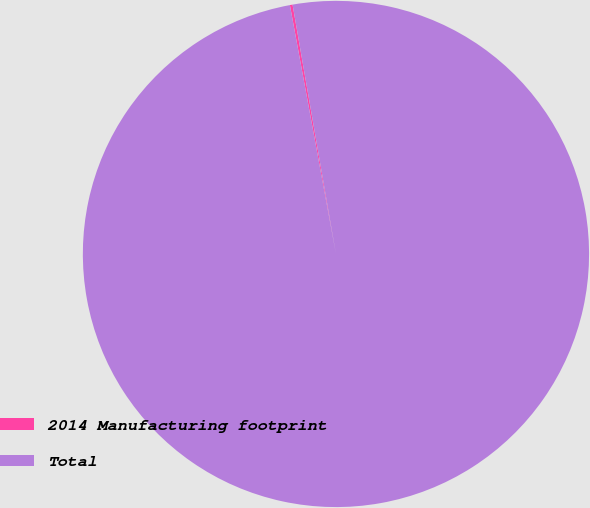<chart> <loc_0><loc_0><loc_500><loc_500><pie_chart><fcel>2014 Manufacturing footprint<fcel>Total<nl><fcel>0.17%<fcel>99.83%<nl></chart> 